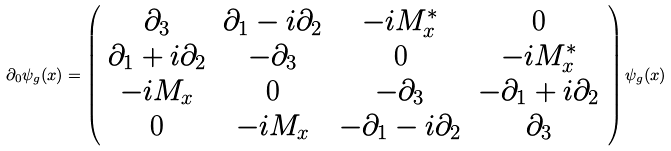Convert formula to latex. <formula><loc_0><loc_0><loc_500><loc_500>\partial _ { 0 } \psi _ { g } ( x ) = \left ( \begin{array} { c c c c } \partial _ { 3 } & \partial _ { 1 } - i \partial _ { 2 } & - i M _ { x } ^ { * } & 0 \\ \partial _ { 1 } + i \partial _ { 2 } & - \partial _ { 3 } & 0 & - i M _ { x } ^ { * } \\ - i M _ { x } & 0 & - \partial _ { 3 } & - \partial _ { 1 } + i \partial _ { 2 } \\ 0 & - i M _ { x } & - \partial _ { 1 } - i \partial _ { 2 } & \partial _ { 3 } \end{array} \right ) \psi _ { g } ( x ) \,</formula> 